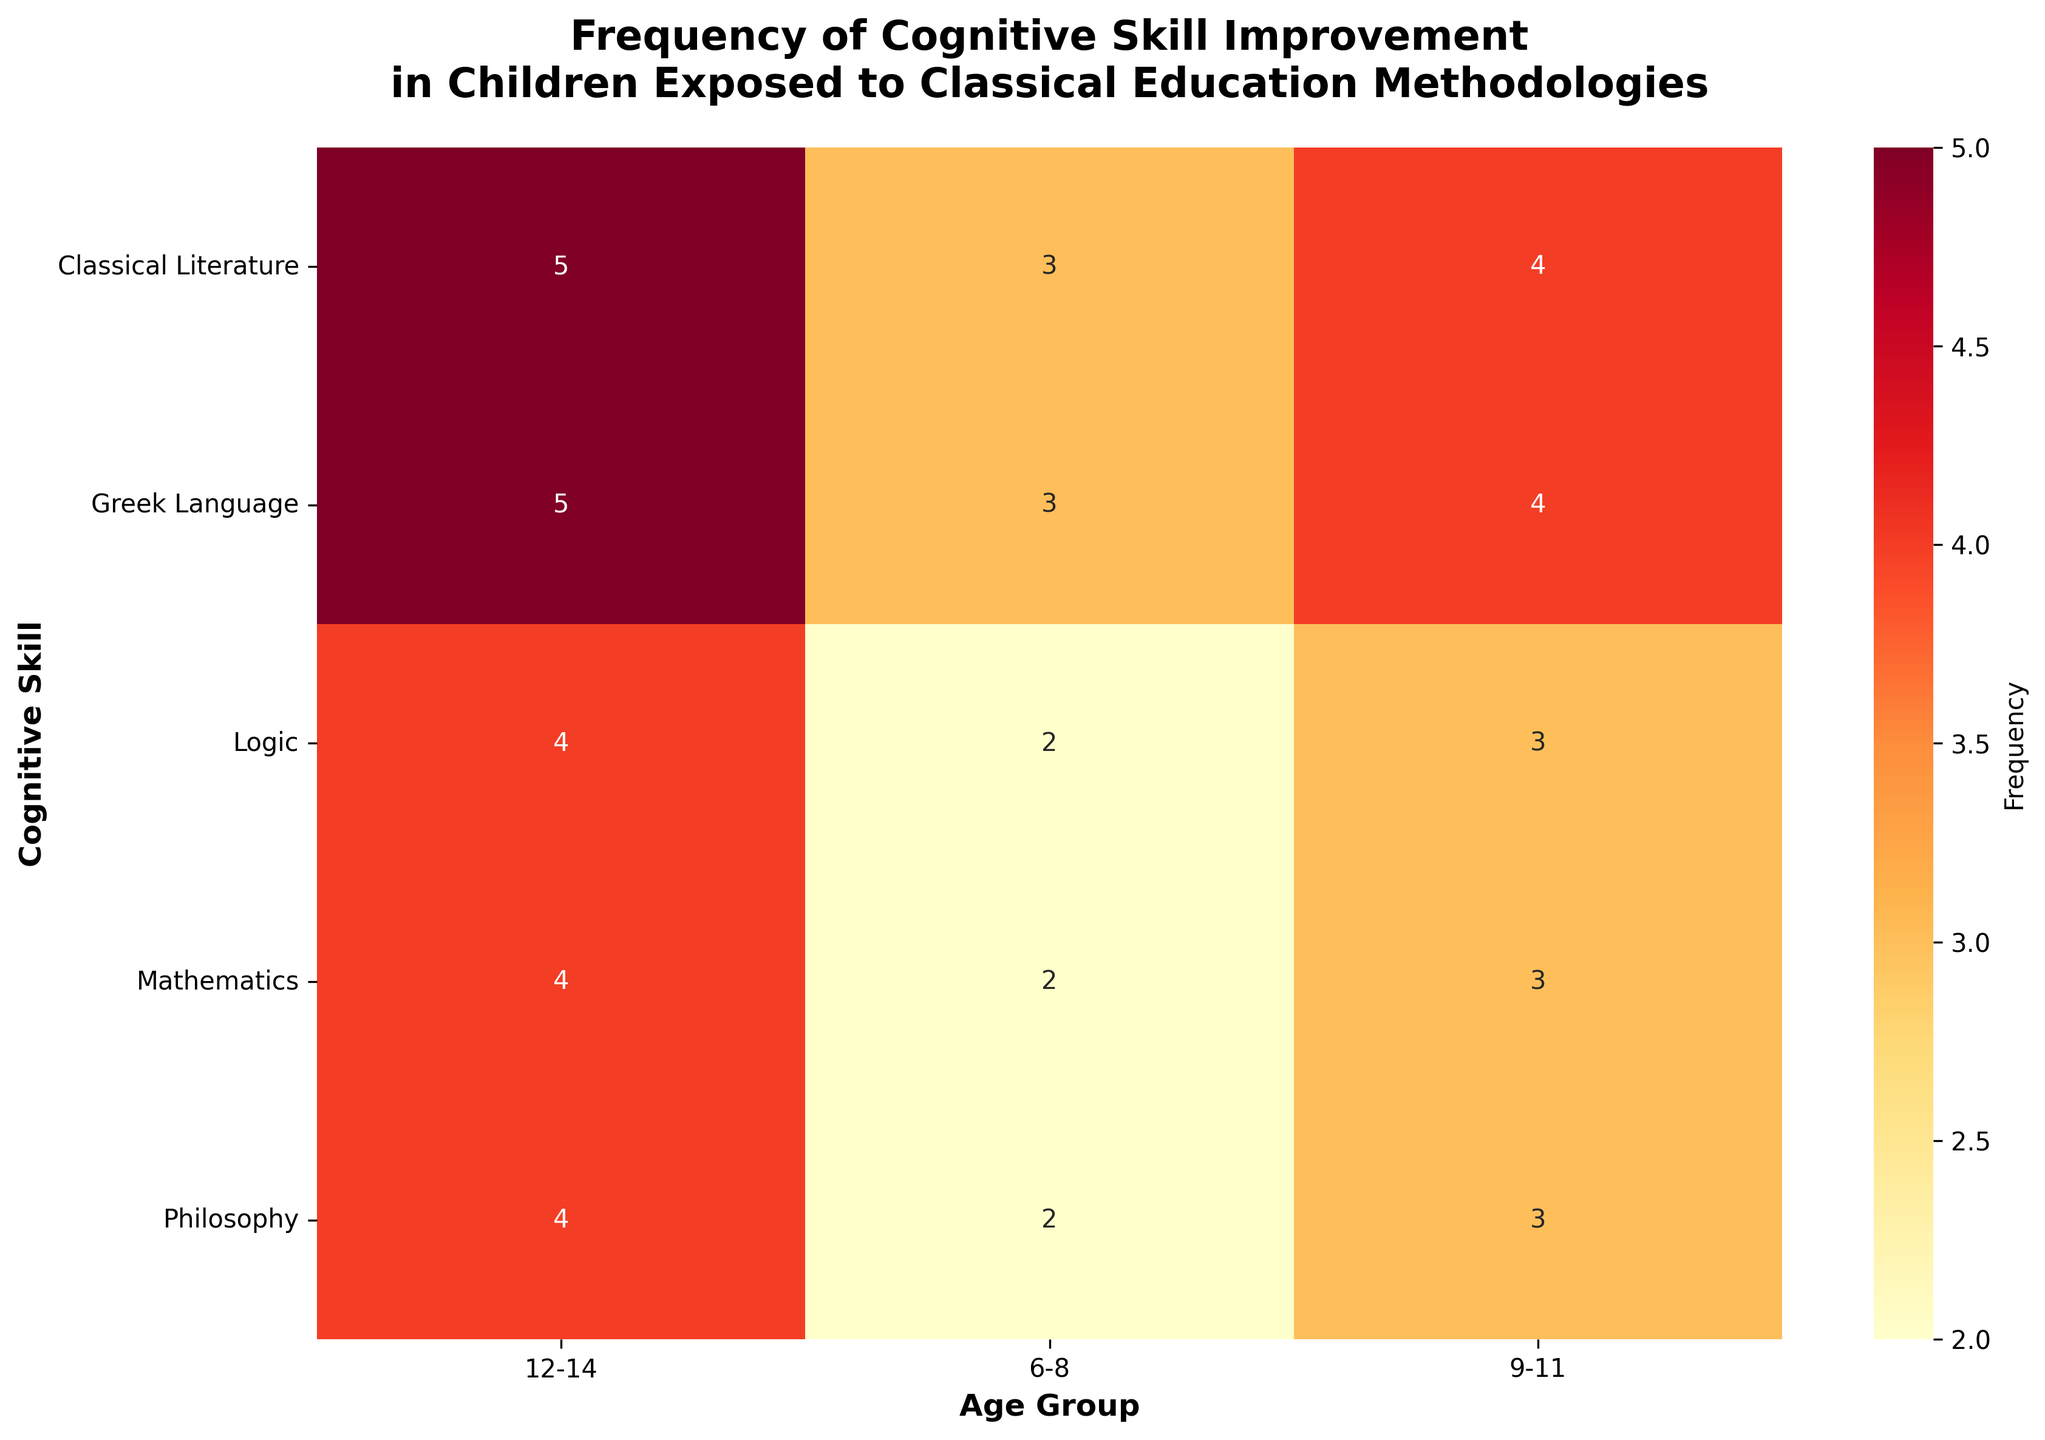Which cognitive skill improves the most among children aged 12-14 in the context of classical literature? Refer to the data for the classical literature at age 12-14 and identify the highest value for the cognitive skills listed. The values are: Memory Retention (5), Logical Reasoning (4), Attention Span (6), Language Proficiency (5), Creativity (4). The maximum value is 6 for Attention Span.
Answer: Attention Span What is the average frequency of improvement in Memory Retention for children across all age groups in the context of mathematics? For Memory Retention in Mathematics, the values are 2 (6-8), 3 (9-11), and 4 (12-14). Calculate the average: (2 + 3 + 4) / 3 = 3.
Answer: 3 Which cognitive skill shows the least improvement for children aged 9-11 in the context of philosophy? Refer to the data for the philosophy at age 9-11 and identify the smallest value for the cognitive skills listed. The values are: Memory Retention (3), Logical Reasoning (3), Attention Span (2), Language Proficiency (2), Creativity (4). The smallest value is 2 for both Attention Span and Language Proficiency.
Answer: Attention Span and Language Proficiency Compare the improvement in Logical Reasoning between children aged 9-11 in classical literature and Greek language. Which has a higher value? For Logical Reasoning, at age 9-11, the values are: Classical Literature (3) and Greek Language (3). Both have the same value of 3.
Answer: Equal In the context of philosophy, which age group shows the highest frequency in Creativity improvement? Refer to the data for philosophy across age groups and identify the highest value for Creativity. The values are: 6-8 (3), 9-11 (4), 12-14 (5). The highest value is 5 for the age group 12-14.
Answer: 12-14 What is the difference in the frequency of improvement in Language Proficiency between children aged 6-8 and 12-14 for logic? For Language Proficiency in Logic, the values are 6-8 (2) and 12-14 (4). Calculate the difference: 4 - 2 = 2.
Answer: 2 Which age group has the highest overall improvement in cognitive skills for classical literature? Sum the values across the cognitive skills for each age group in classical literature: 
6-8: 3 + 2 + 4 + 3 + 2 = 14 
9-11: 4 + 3 + 5 + 4 + 3 = 19 
12-14: 5 + 4 + 6 + 5 + 4 = 24 
Hence, the age group 12-14 has the highest sum.
Answer: 12-14 How does the frequency of Memory Retention improvement compare between the Greek language for children aged 6-8 and 9-11? For Memory Retention in Greek language, the values are 6-8 (3) and 9-11 (4). 4 is greater than 3.
Answer: 9-11 is greater Summing up the frequencies of improvement for Attention Span in the context of all cognitive skills for children aged 6-8, what is the total? For Attention Span in age group 6-8, the values are: Classical Literature (4), Mathematics (3), Philosophy (1), Greek Language (2), Logic (3). Sum of these values: 4 + 3 + 1 + 2 + 3 = 13.
Answer: 13 Which cognitive skill has the same frequency of improvement across all age groups in the context of Greek language? For Greek language, check if a cognitive skill has the same value across all age groups:
Memory Retention (6-8: 3, 9-11: 4, 12-14: 5)
Logical Reasoning (6-8: 2, 9-11: 3, 12-14: 4)
Attention Span (6-8: 2, 9-11: 3, 12-14: 4)
Language Proficiency (6-8: 4, 9-11: 5, 12-14: 6)
Creativity (6-8: 2, 9-11: 3, 12-14: 4)
None of the cognitive skills have the same frequency across all age groups.
Answer: None 